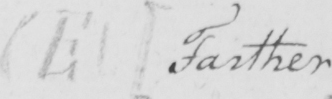Can you tell me what this handwritten text says? ( E )   [ Farther ] 